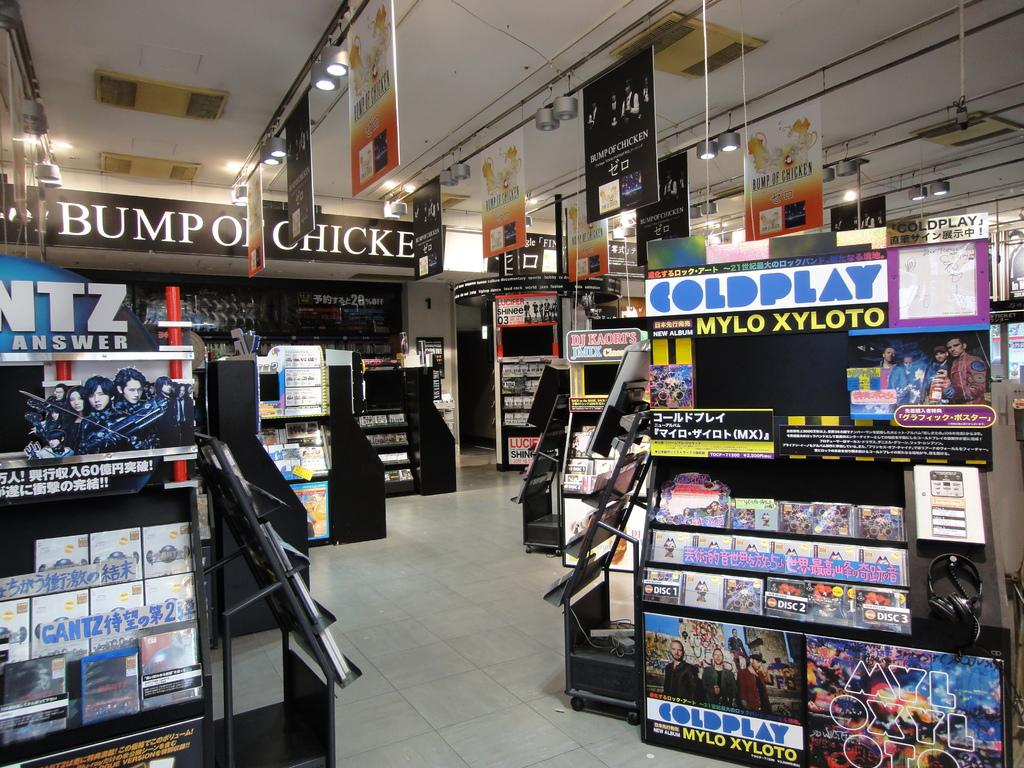<image>
Relay a brief, clear account of the picture shown. The band Coldplay is being adverstised inside this store. 